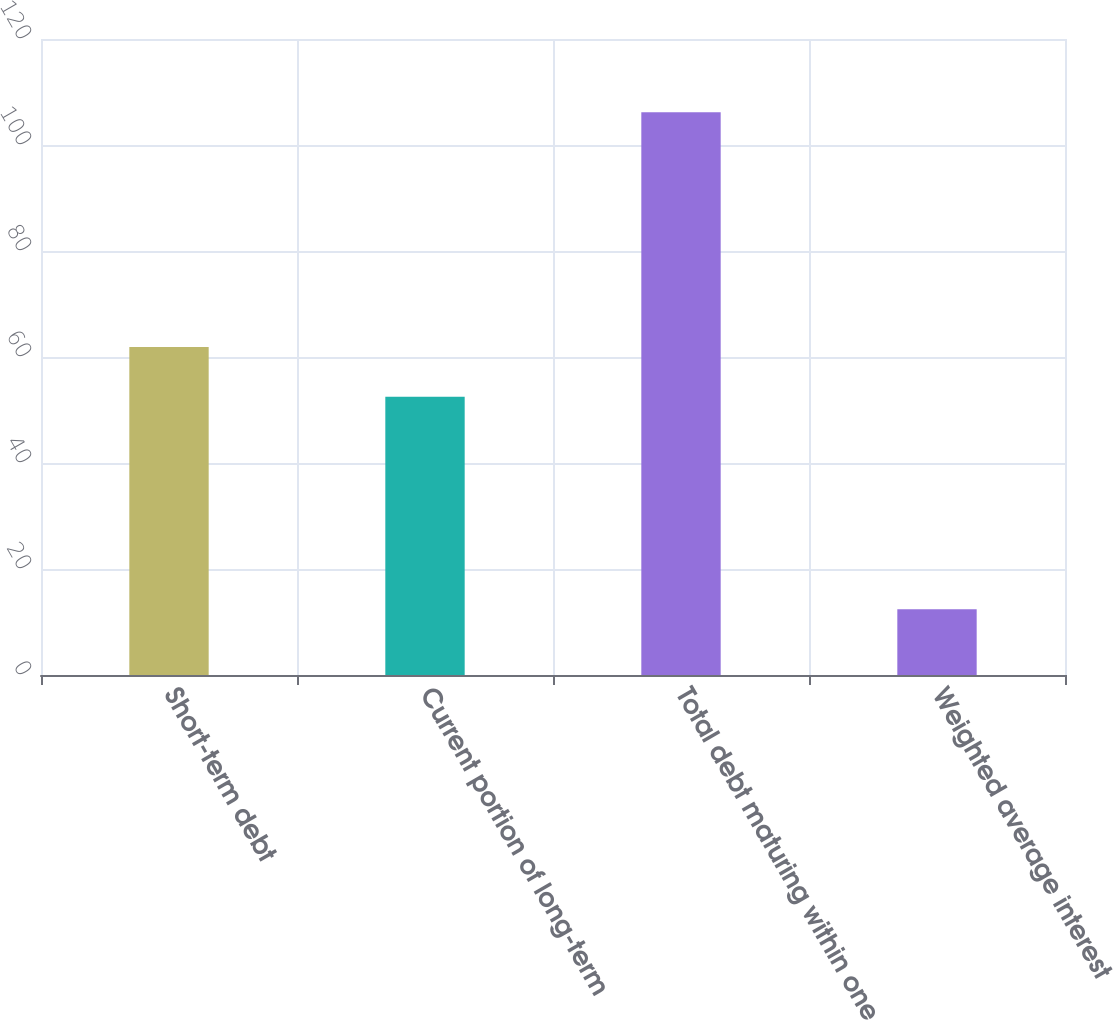Convert chart to OTSL. <chart><loc_0><loc_0><loc_500><loc_500><bar_chart><fcel>Short-term debt<fcel>Current portion of long-term<fcel>Total debt maturing within one<fcel>Weighted average interest<nl><fcel>61.88<fcel>52.5<fcel>106.2<fcel>12.4<nl></chart> 